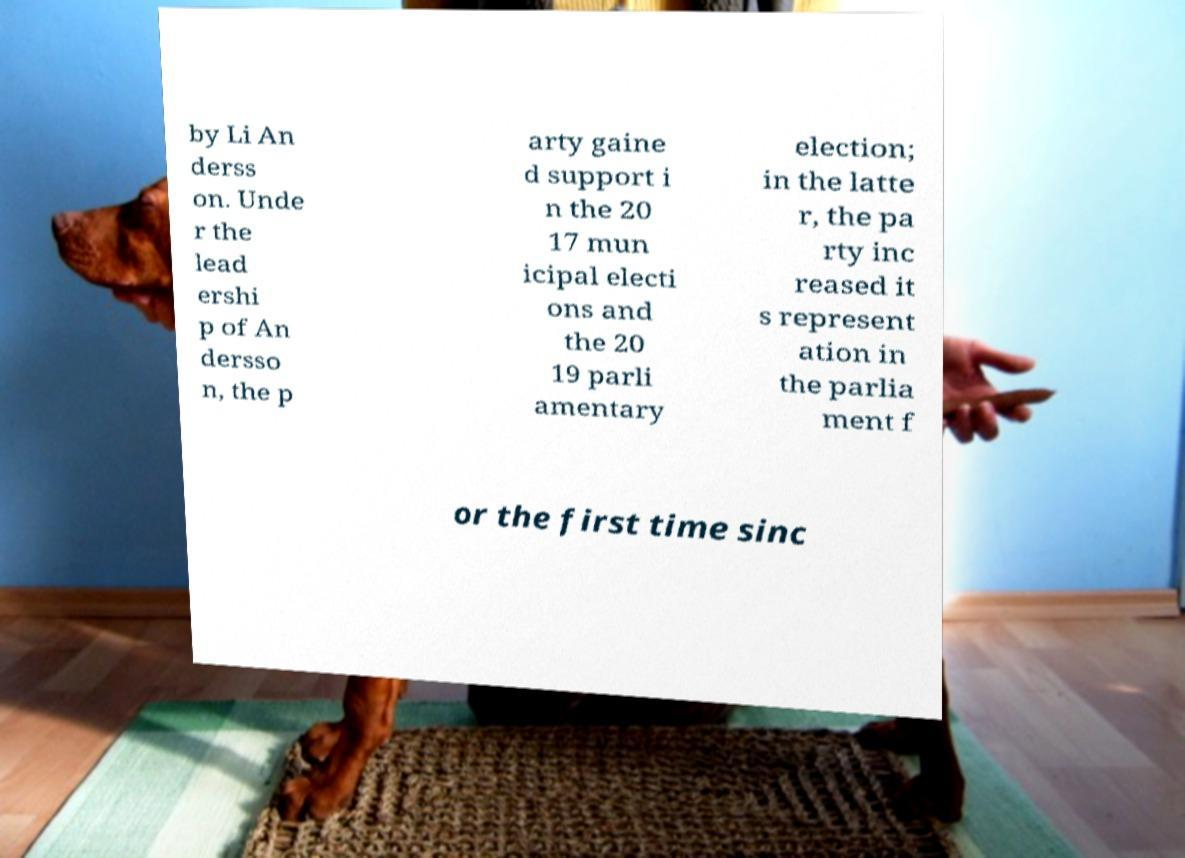Please read and relay the text visible in this image. What does it say? by Li An derss on. Unde r the lead ershi p of An dersso n, the p arty gaine d support i n the 20 17 mun icipal electi ons and the 20 19 parli amentary election; in the latte r, the pa rty inc reased it s represent ation in the parlia ment f or the first time sinc 